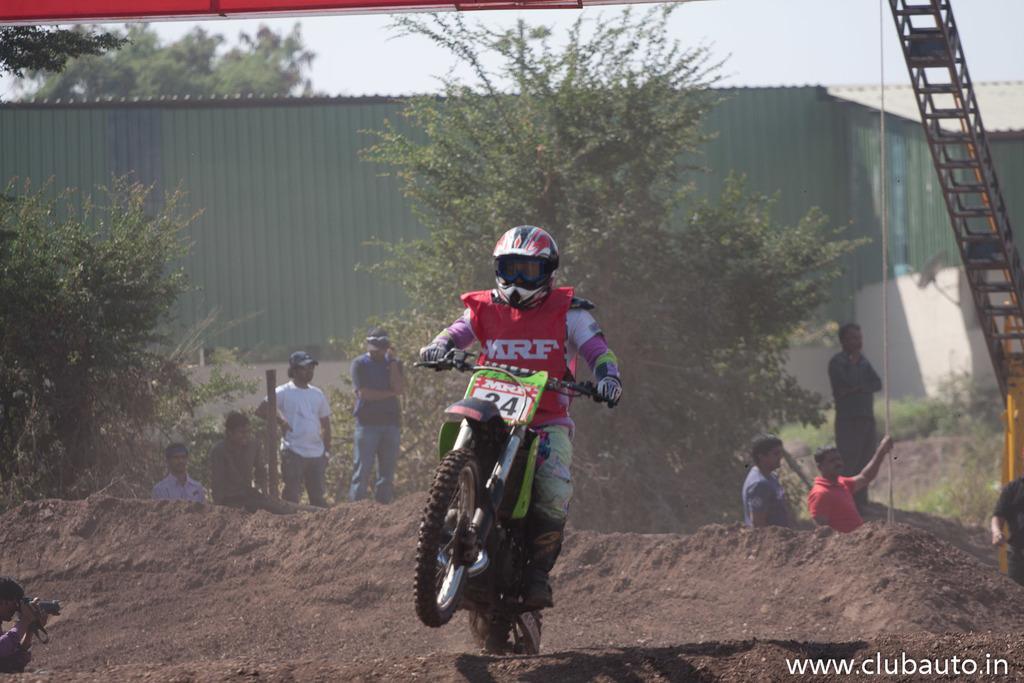How would you summarize this image in a sentence or two? In the picture we can see a person riding a sports bike and he is in a sportswear and helmet and he is riding on the mud surface and behind him we can see some people are standing and some some plants beside them and behind them we can see a shed and behind it we can see some tree and sky. 